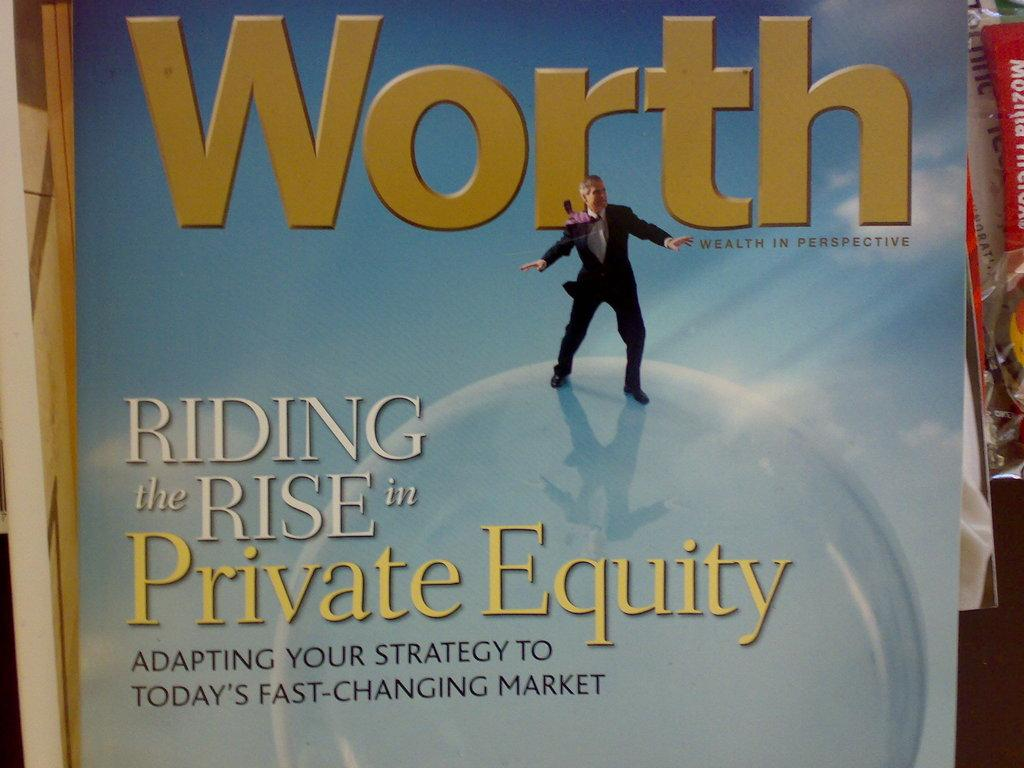<image>
Relay a brief, clear account of the picture shown. Cover for Worth showing a man in a suit on top of a bubble. 